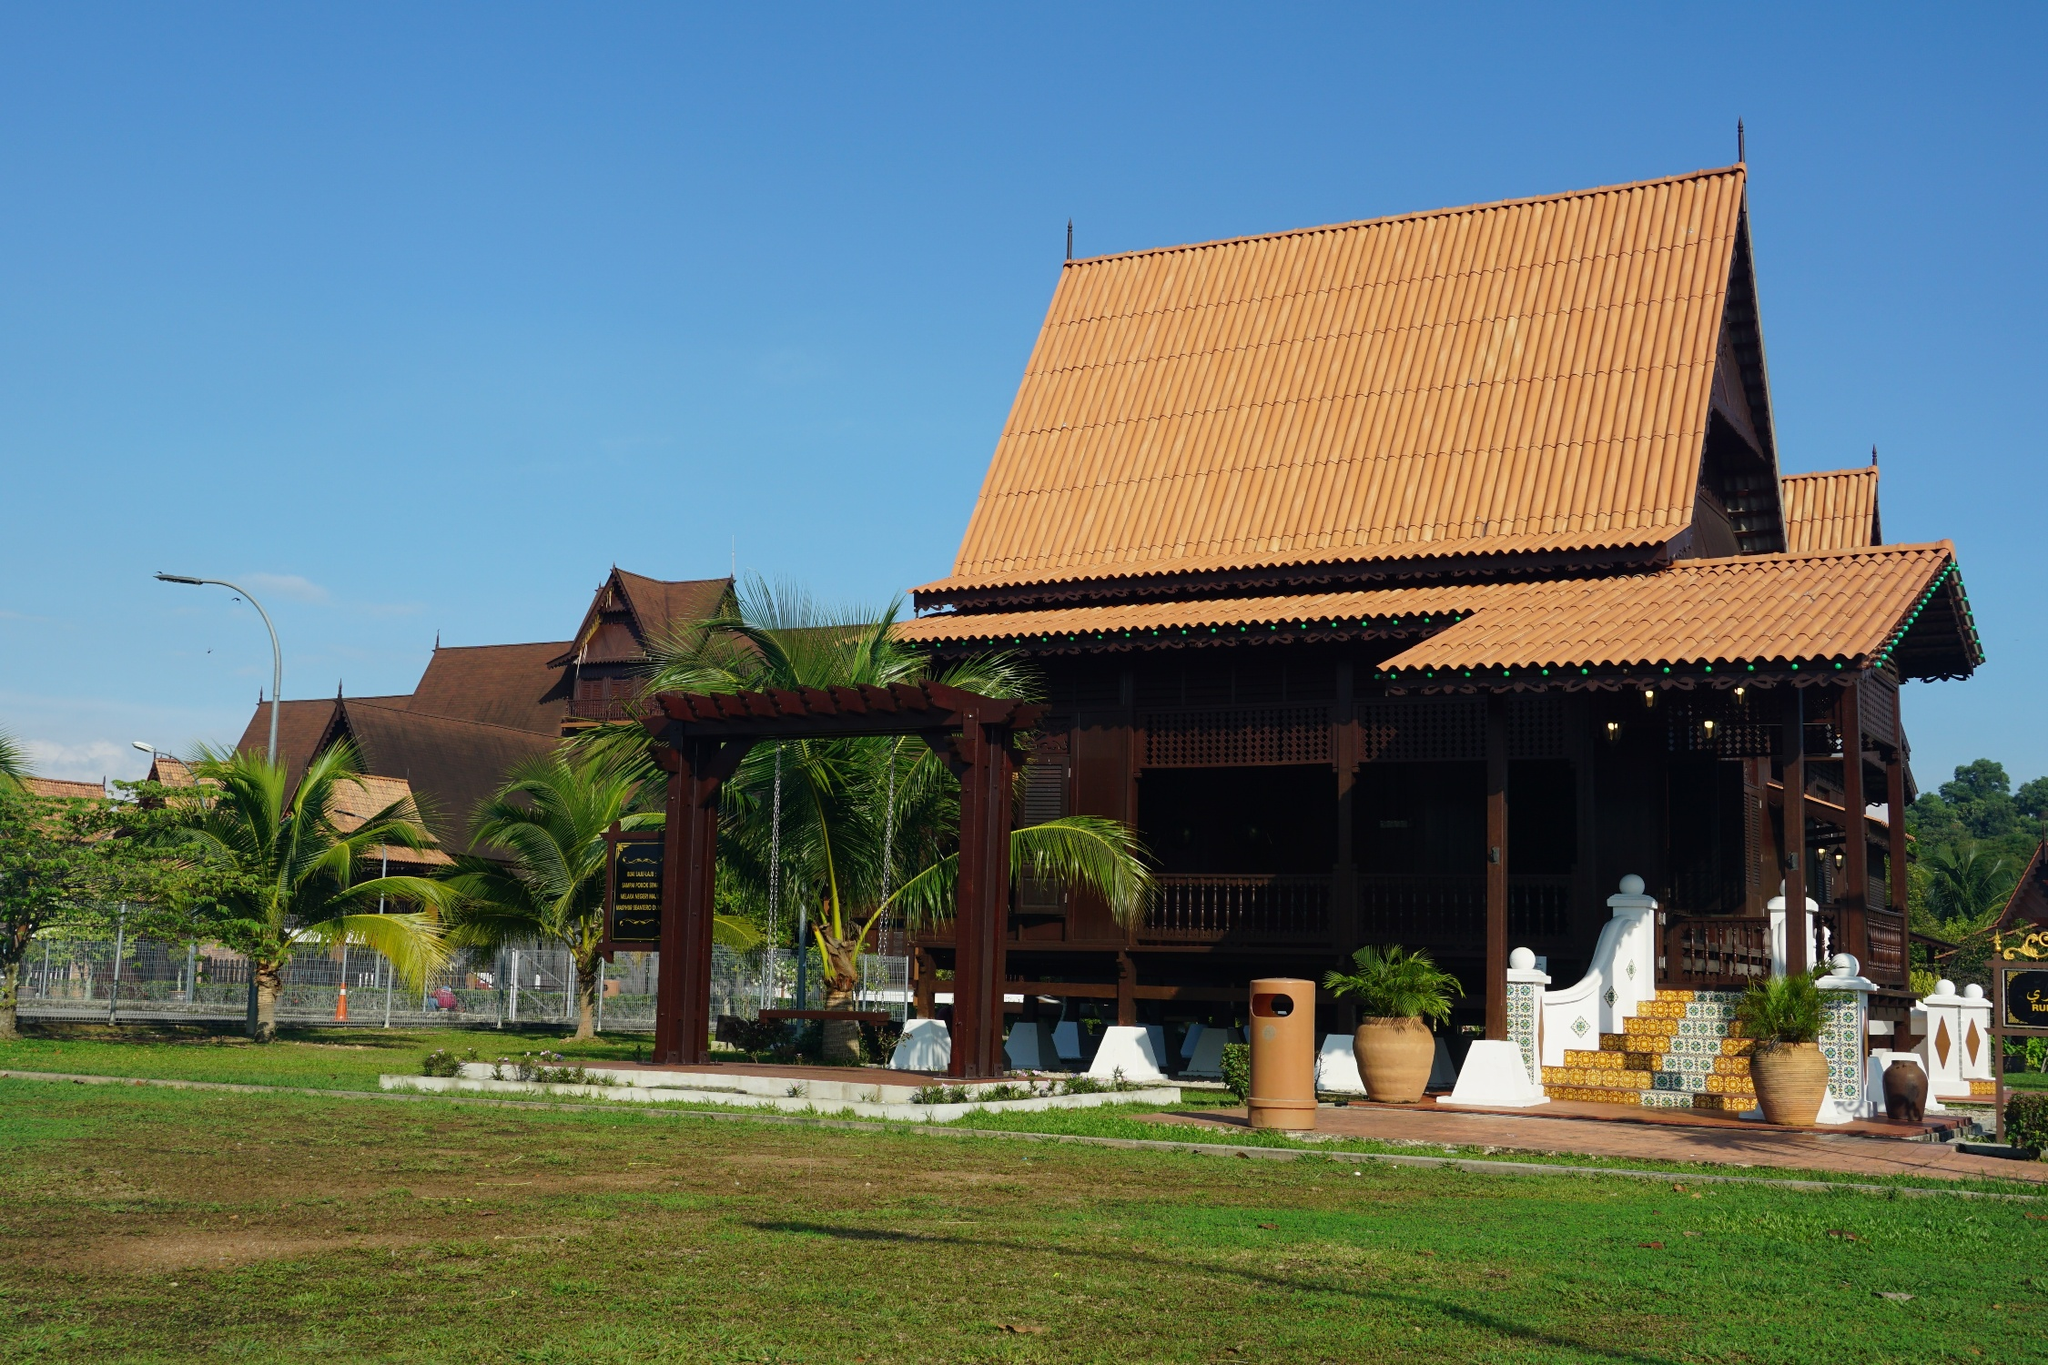Can you elaborate on the elements of the picture provided? The image beautifully captures a traditional Thai house, a quintessential representation of Thailand's rich architectural heritage. The house stands out with its characteristic red-tiled roof and pristine white walls, creating a vivid contrast against the clear blue sky. The elevated structure is a common feature in Thai architecture, designed to protect against flooding during the rainy season. The steeply pitched roof, layered with meticulous detail, is not just aesthetically pleasing but also functional, aiding in the drainage of heavy rainfall typical of the tropical climate.

Surrounding the house is a lush green lawn, adorned with swaying palm trees that enhance the tropical ambiance of the scene. The angle of the photograph is taken from below, looking up, which emphasizes the grandeur and elegance of the house. One can also appreciate the intricate wooden carvings and details, a testament to Thai craftsmanship and tradition.

Despite thorough efforts, specific information about the landmark code 'sa_10717' could not be found. Providing additional context or a different identifier may be beneficial in obtaining more detailed information. 